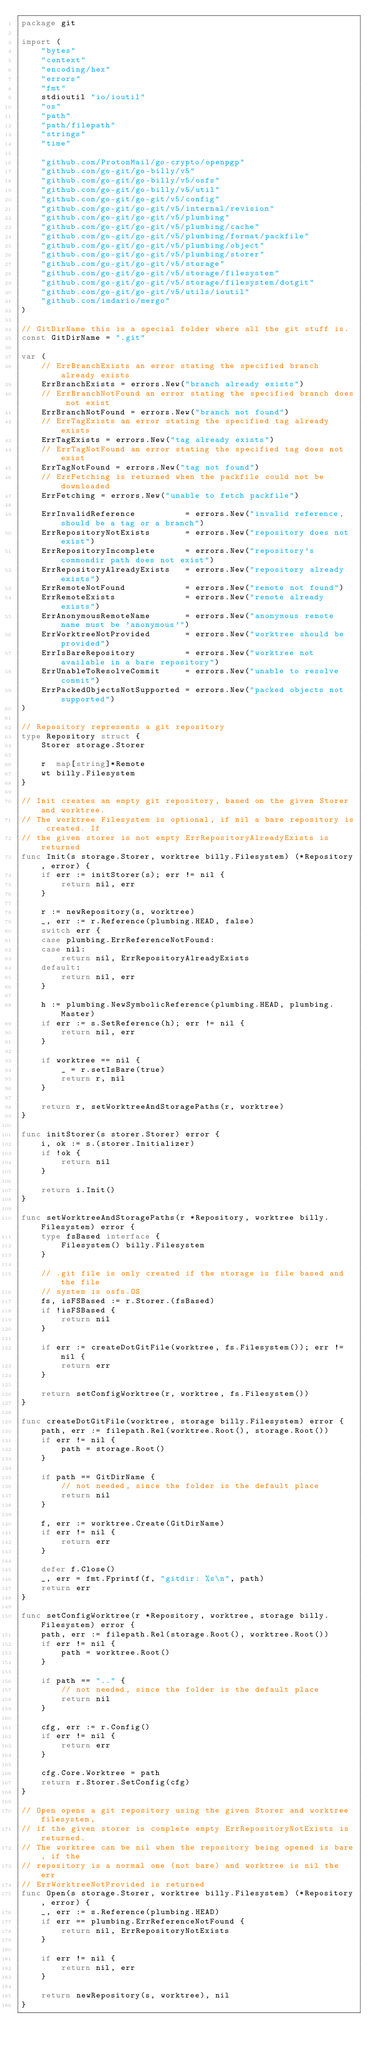<code> <loc_0><loc_0><loc_500><loc_500><_Go_>package git

import (
	"bytes"
	"context"
	"encoding/hex"
	"errors"
	"fmt"
	stdioutil "io/ioutil"
	"os"
	"path"
	"path/filepath"
	"strings"
	"time"

	"github.com/ProtonMail/go-crypto/openpgp"
	"github.com/go-git/go-billy/v5"
	"github.com/go-git/go-billy/v5/osfs"
	"github.com/go-git/go-billy/v5/util"
	"github.com/go-git/go-git/v5/config"
	"github.com/go-git/go-git/v5/internal/revision"
	"github.com/go-git/go-git/v5/plumbing"
	"github.com/go-git/go-git/v5/plumbing/cache"
	"github.com/go-git/go-git/v5/plumbing/format/packfile"
	"github.com/go-git/go-git/v5/plumbing/object"
	"github.com/go-git/go-git/v5/plumbing/storer"
	"github.com/go-git/go-git/v5/storage"
	"github.com/go-git/go-git/v5/storage/filesystem"
	"github.com/go-git/go-git/v5/storage/filesystem/dotgit"
	"github.com/go-git/go-git/v5/utils/ioutil"
	"github.com/imdario/mergo"
)

// GitDirName this is a special folder where all the git stuff is.
const GitDirName = ".git"

var (
	// ErrBranchExists an error stating the specified branch already exists
	ErrBranchExists = errors.New("branch already exists")
	// ErrBranchNotFound an error stating the specified branch does not exist
	ErrBranchNotFound = errors.New("branch not found")
	// ErrTagExists an error stating the specified tag already exists
	ErrTagExists = errors.New("tag already exists")
	// ErrTagNotFound an error stating the specified tag does not exist
	ErrTagNotFound = errors.New("tag not found")
	// ErrFetching is returned when the packfile could not be downloaded
	ErrFetching = errors.New("unable to fetch packfile")

	ErrInvalidReference          = errors.New("invalid reference, should be a tag or a branch")
	ErrRepositoryNotExists       = errors.New("repository does not exist")
	ErrRepositoryIncomplete      = errors.New("repository's commondir path does not exist")
	ErrRepositoryAlreadyExists   = errors.New("repository already exists")
	ErrRemoteNotFound            = errors.New("remote not found")
	ErrRemoteExists              = errors.New("remote already exists")
	ErrAnonymousRemoteName       = errors.New("anonymous remote name must be 'anonymous'")
	ErrWorktreeNotProvided       = errors.New("worktree should be provided")
	ErrIsBareRepository          = errors.New("worktree not available in a bare repository")
	ErrUnableToResolveCommit     = errors.New("unable to resolve commit")
	ErrPackedObjectsNotSupported = errors.New("packed objects not supported")
)

// Repository represents a git repository
type Repository struct {
	Storer storage.Storer

	r  map[string]*Remote
	wt billy.Filesystem
}

// Init creates an empty git repository, based on the given Storer and worktree.
// The worktree Filesystem is optional, if nil a bare repository is created. If
// the given storer is not empty ErrRepositoryAlreadyExists is returned
func Init(s storage.Storer, worktree billy.Filesystem) (*Repository, error) {
	if err := initStorer(s); err != nil {
		return nil, err
	}

	r := newRepository(s, worktree)
	_, err := r.Reference(plumbing.HEAD, false)
	switch err {
	case plumbing.ErrReferenceNotFound:
	case nil:
		return nil, ErrRepositoryAlreadyExists
	default:
		return nil, err
	}

	h := plumbing.NewSymbolicReference(plumbing.HEAD, plumbing.Master)
	if err := s.SetReference(h); err != nil {
		return nil, err
	}

	if worktree == nil {
		_ = r.setIsBare(true)
		return r, nil
	}

	return r, setWorktreeAndStoragePaths(r, worktree)
}

func initStorer(s storer.Storer) error {
	i, ok := s.(storer.Initializer)
	if !ok {
		return nil
	}

	return i.Init()
}

func setWorktreeAndStoragePaths(r *Repository, worktree billy.Filesystem) error {
	type fsBased interface {
		Filesystem() billy.Filesystem
	}

	// .git file is only created if the storage is file based and the file
	// system is osfs.OS
	fs, isFSBased := r.Storer.(fsBased)
	if !isFSBased {
		return nil
	}

	if err := createDotGitFile(worktree, fs.Filesystem()); err != nil {
		return err
	}

	return setConfigWorktree(r, worktree, fs.Filesystem())
}

func createDotGitFile(worktree, storage billy.Filesystem) error {
	path, err := filepath.Rel(worktree.Root(), storage.Root())
	if err != nil {
		path = storage.Root()
	}

	if path == GitDirName {
		// not needed, since the folder is the default place
		return nil
	}

	f, err := worktree.Create(GitDirName)
	if err != nil {
		return err
	}

	defer f.Close()
	_, err = fmt.Fprintf(f, "gitdir: %s\n", path)
	return err
}

func setConfigWorktree(r *Repository, worktree, storage billy.Filesystem) error {
	path, err := filepath.Rel(storage.Root(), worktree.Root())
	if err != nil {
		path = worktree.Root()
	}

	if path == ".." {
		// not needed, since the folder is the default place
		return nil
	}

	cfg, err := r.Config()
	if err != nil {
		return err
	}

	cfg.Core.Worktree = path
	return r.Storer.SetConfig(cfg)
}

// Open opens a git repository using the given Storer and worktree filesystem,
// if the given storer is complete empty ErrRepositoryNotExists is returned.
// The worktree can be nil when the repository being opened is bare, if the
// repository is a normal one (not bare) and worktree is nil the err
// ErrWorktreeNotProvided is returned
func Open(s storage.Storer, worktree billy.Filesystem) (*Repository, error) {
	_, err := s.Reference(plumbing.HEAD)
	if err == plumbing.ErrReferenceNotFound {
		return nil, ErrRepositoryNotExists
	}

	if err != nil {
		return nil, err
	}

	return newRepository(s, worktree), nil
}
</code> 